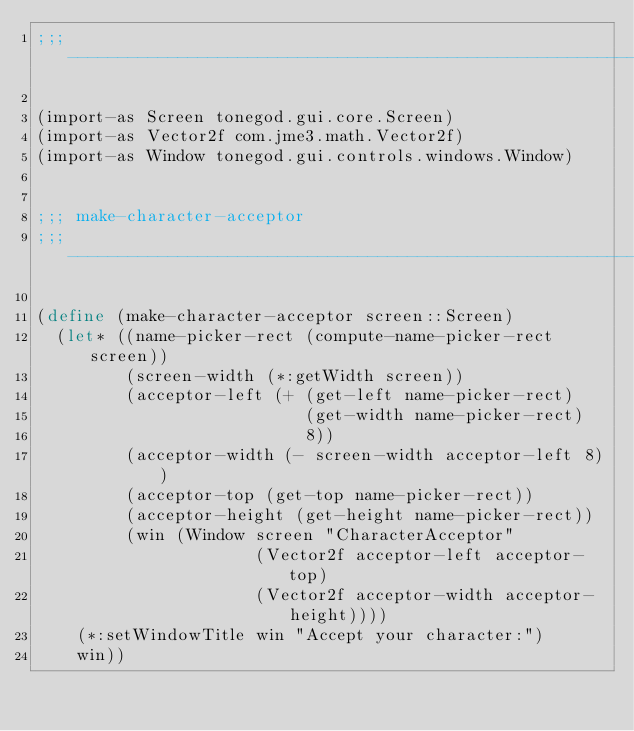Convert code to text. <code><loc_0><loc_0><loc_500><loc_500><_Scheme_>;;; ---------------------------------------------------------------------

(import-as Screen tonegod.gui.core.Screen)
(import-as Vector2f com.jme3.math.Vector2f)
(import-as Window tonegod.gui.controls.windows.Window)


;;; make-character-acceptor
;;; ---------------------------------------------------------------------

(define (make-character-acceptor screen::Screen)
  (let* ((name-picker-rect (compute-name-picker-rect screen))
         (screen-width (*:getWidth screen))
         (acceptor-left (+ (get-left name-picker-rect)
                           (get-width name-picker-rect)
                           8))
         (acceptor-width (- screen-width acceptor-left 8))
         (acceptor-top (get-top name-picker-rect))
         (acceptor-height (get-height name-picker-rect))
         (win (Window screen "CharacterAcceptor"
                      (Vector2f acceptor-left acceptor-top)
                      (Vector2f acceptor-width acceptor-height))))
    (*:setWindowTitle win "Accept your character:")
    win))
</code> 